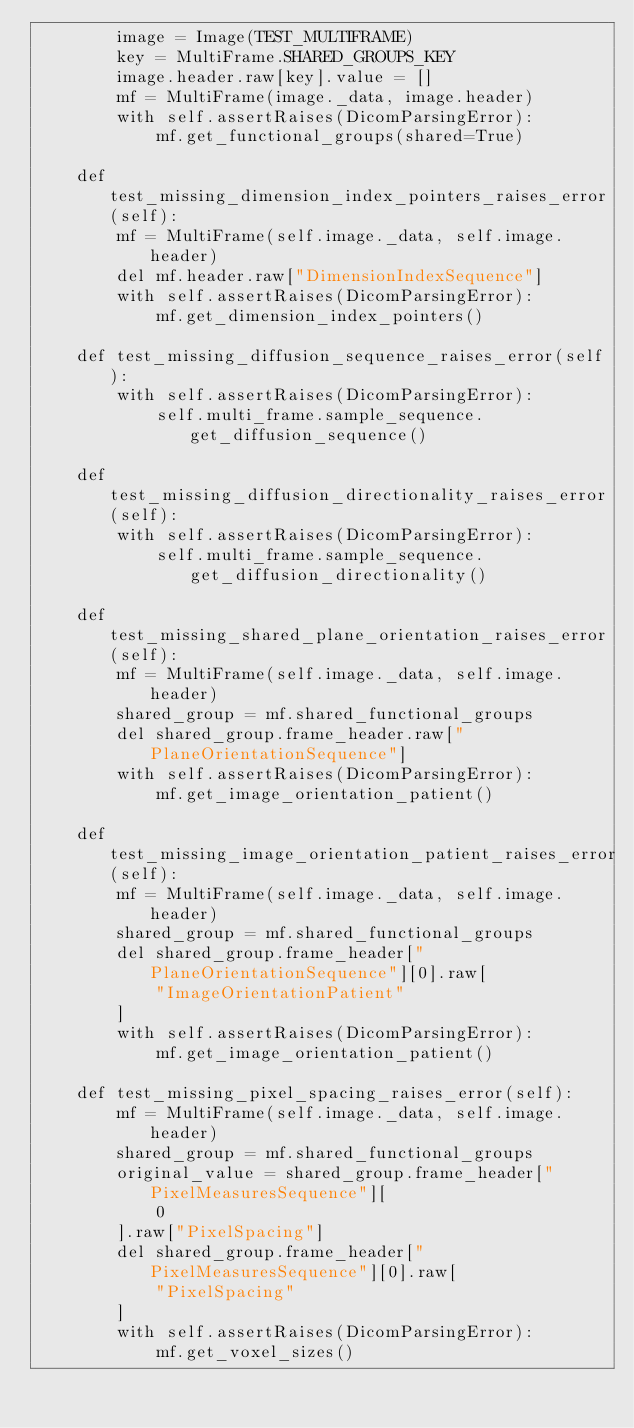Convert code to text. <code><loc_0><loc_0><loc_500><loc_500><_Python_>        image = Image(TEST_MULTIFRAME)
        key = MultiFrame.SHARED_GROUPS_KEY
        image.header.raw[key].value = []
        mf = MultiFrame(image._data, image.header)
        with self.assertRaises(DicomParsingError):
            mf.get_functional_groups(shared=True)

    def test_missing_dimension_index_pointers_raises_error(self):
        mf = MultiFrame(self.image._data, self.image.header)
        del mf.header.raw["DimensionIndexSequence"]
        with self.assertRaises(DicomParsingError):
            mf.get_dimension_index_pointers()

    def test_missing_diffusion_sequence_raises_error(self):
        with self.assertRaises(DicomParsingError):
            self.multi_frame.sample_sequence.get_diffusion_sequence()

    def test_missing_diffusion_directionality_raises_error(self):
        with self.assertRaises(DicomParsingError):
            self.multi_frame.sample_sequence.get_diffusion_directionality()

    def test_missing_shared_plane_orientation_raises_error(self):
        mf = MultiFrame(self.image._data, self.image.header)
        shared_group = mf.shared_functional_groups
        del shared_group.frame_header.raw["PlaneOrientationSequence"]
        with self.assertRaises(DicomParsingError):
            mf.get_image_orientation_patient()

    def test_missing_image_orientation_patient_raises_error(self):
        mf = MultiFrame(self.image._data, self.image.header)
        shared_group = mf.shared_functional_groups
        del shared_group.frame_header["PlaneOrientationSequence"][0].raw[
            "ImageOrientationPatient"
        ]
        with self.assertRaises(DicomParsingError):
            mf.get_image_orientation_patient()

    def test_missing_pixel_spacing_raises_error(self):
        mf = MultiFrame(self.image._data, self.image.header)
        shared_group = mf.shared_functional_groups
        original_value = shared_group.frame_header["PixelMeasuresSequence"][
            0
        ].raw["PixelSpacing"]
        del shared_group.frame_header["PixelMeasuresSequence"][0].raw[
            "PixelSpacing"
        ]
        with self.assertRaises(DicomParsingError):
            mf.get_voxel_sizes()</code> 